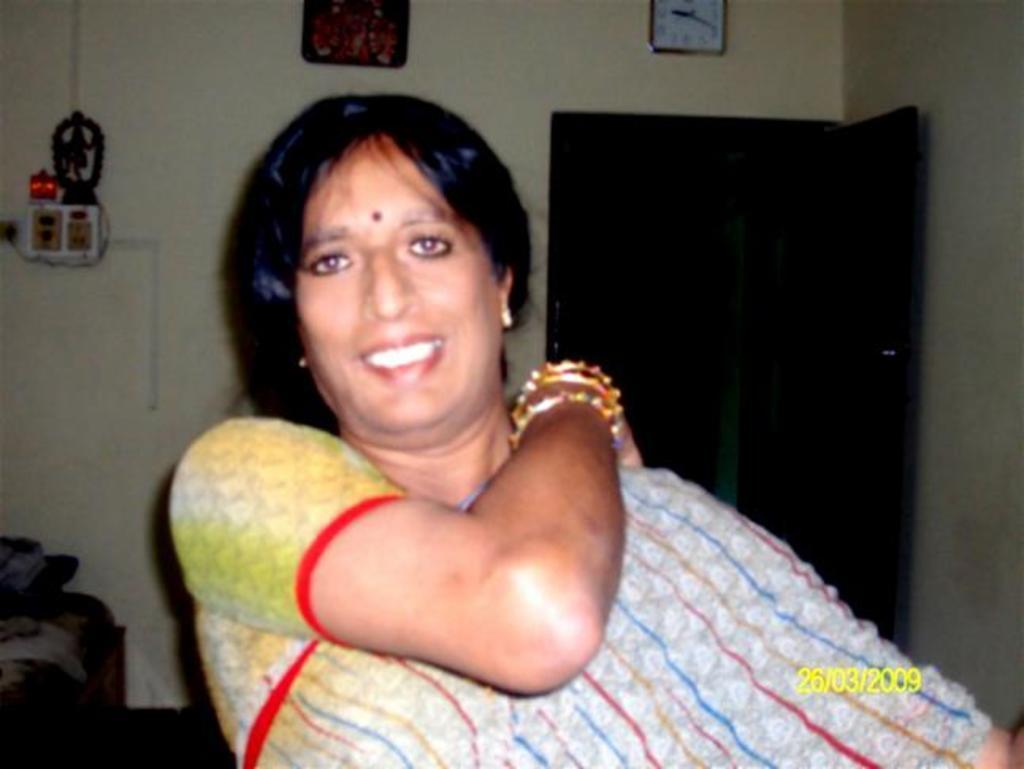Can you describe this image briefly? The woman in front of the picture who is wearing a saree is standing and she is smiling. In the left bottom of the picture, we see a bed and pillows. Behind her, we see a black door and a white wall on which photo frame and wall clock is placed. On the left side, we see a meter board. 